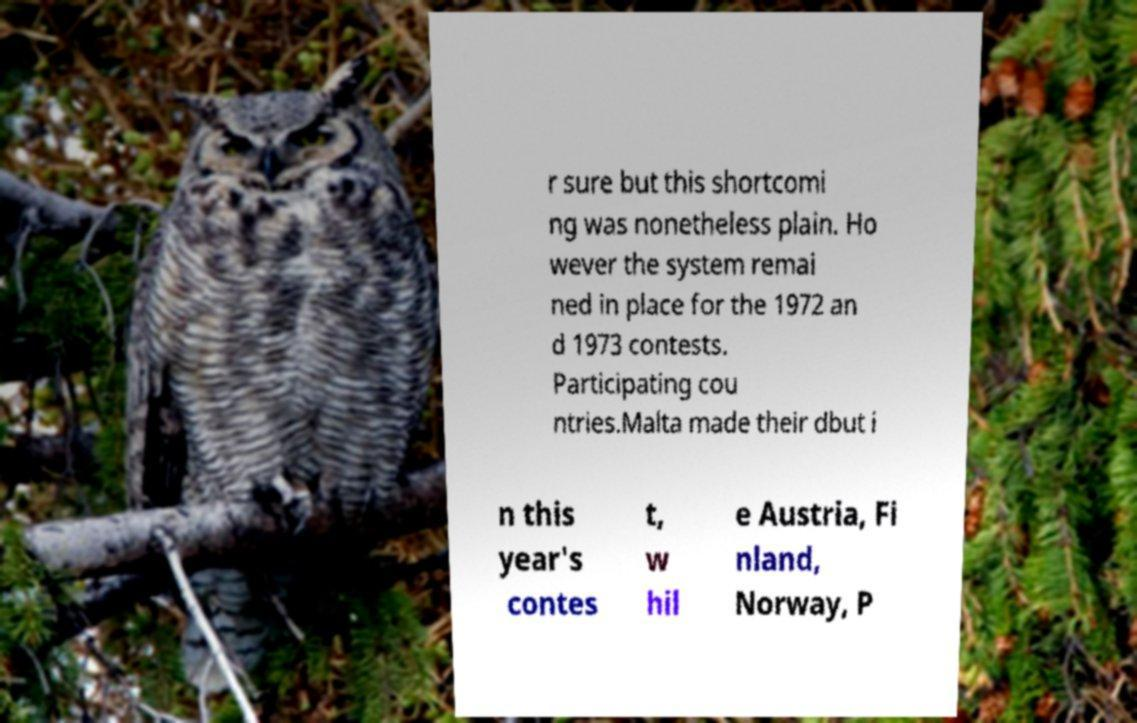Can you accurately transcribe the text from the provided image for me? r sure but this shortcomi ng was nonetheless plain. Ho wever the system remai ned in place for the 1972 an d 1973 contests. Participating cou ntries.Malta made their dbut i n this year's contes t, w hil e Austria, Fi nland, Norway, P 